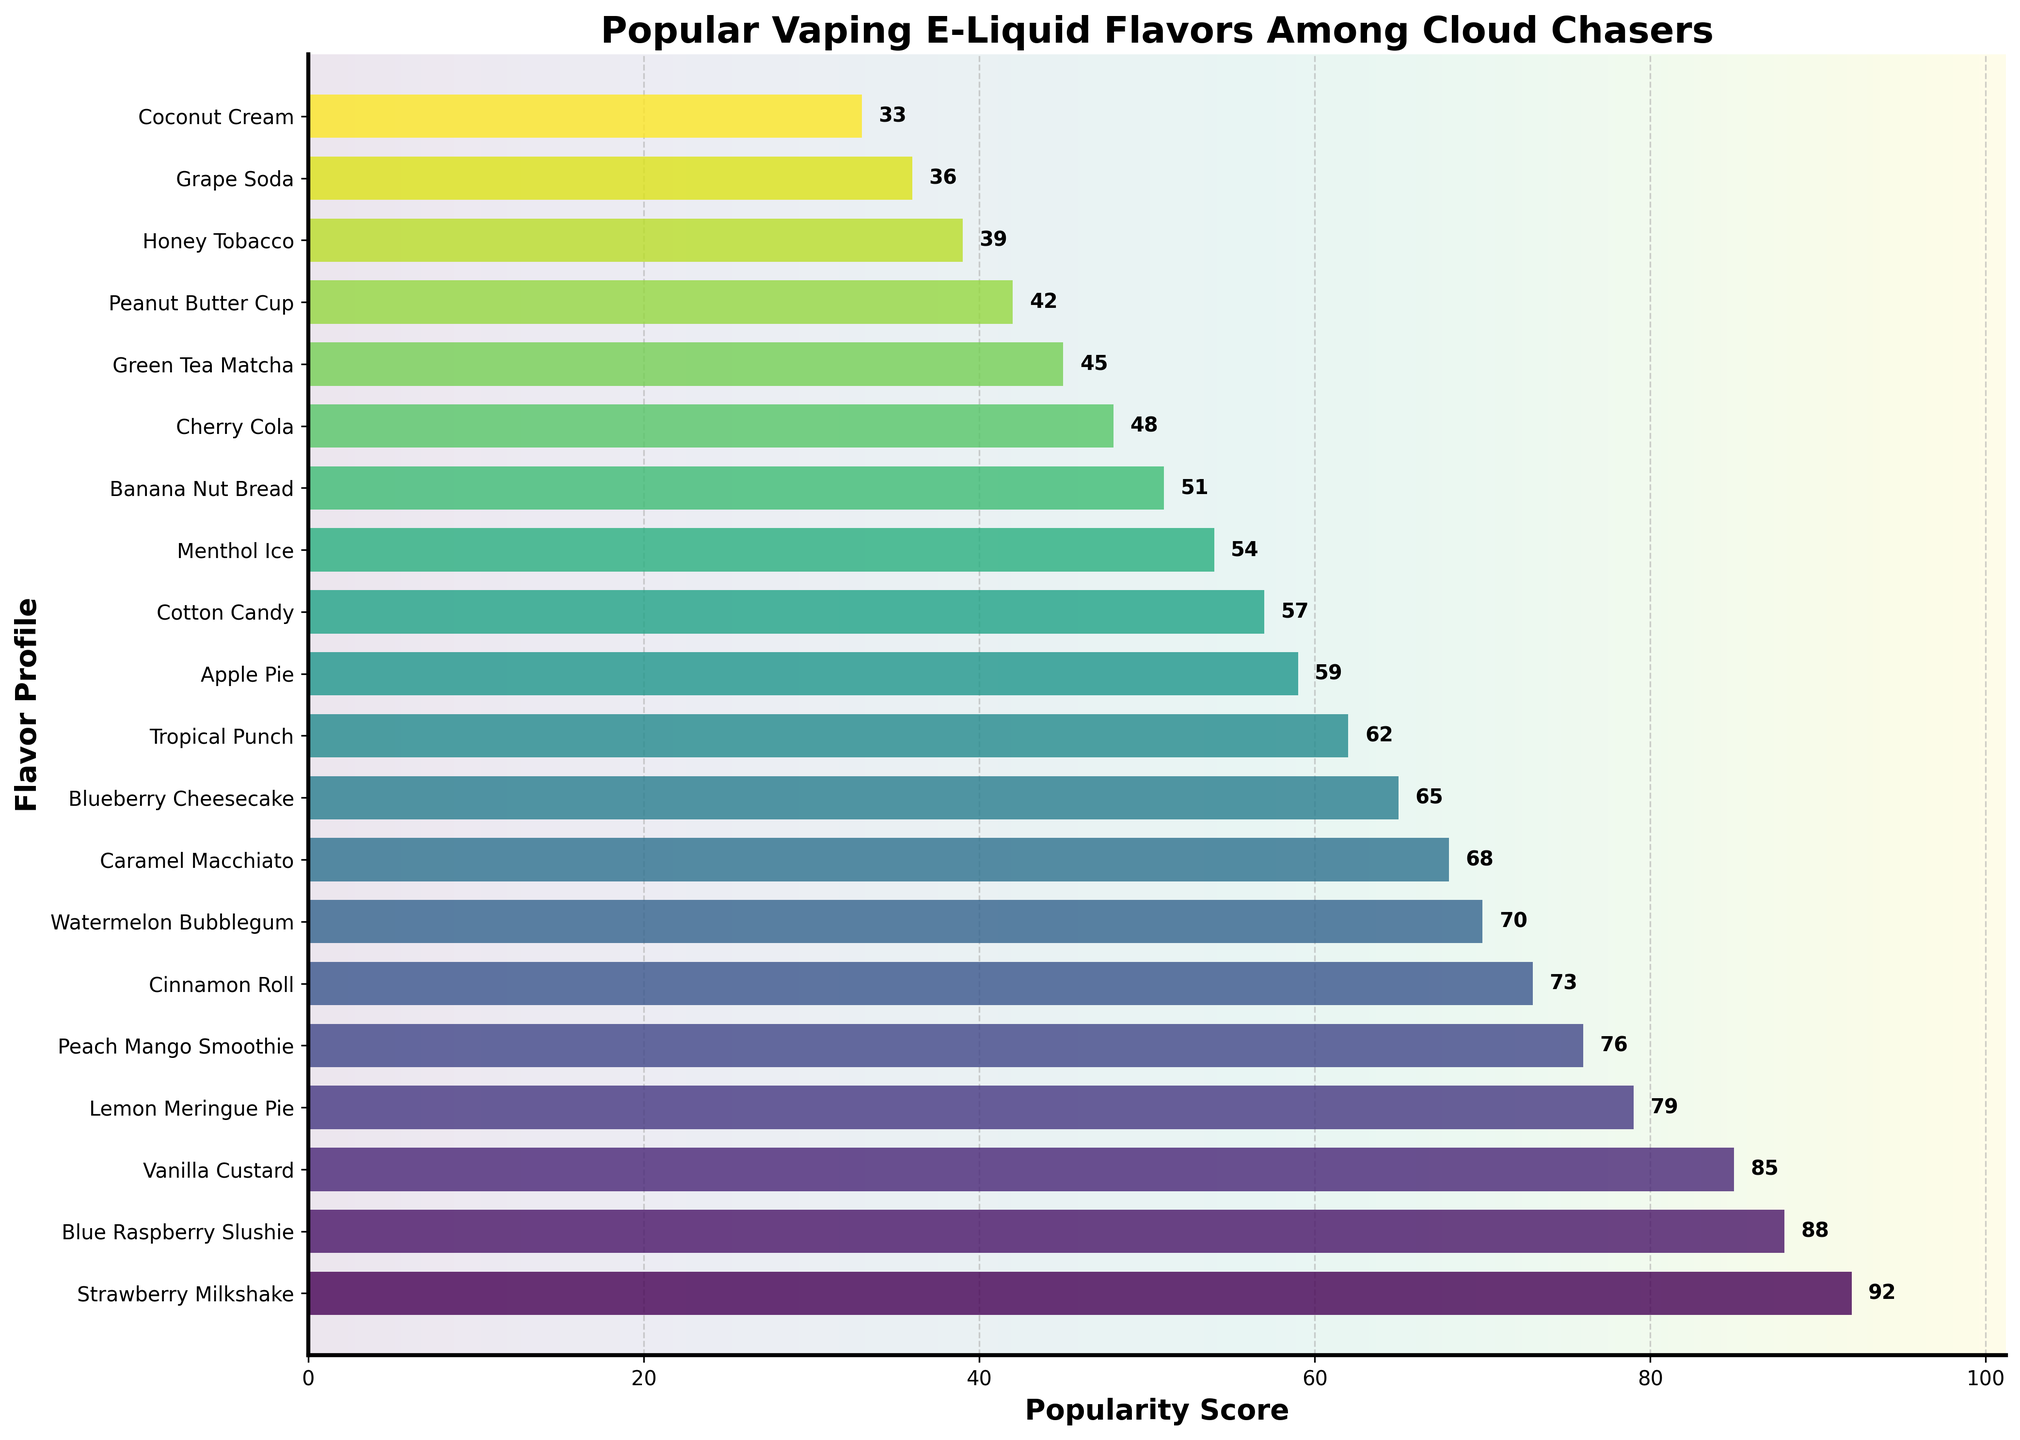what flavor profile has the highest popularity score? By looking at the top of the bar chart, we can see the bar with the highest length, which represents the flavor profile with the highest popularity score.
Answer: Strawberry Milkshake Which flavor profiles have a popularity score greater than 80? We need to identify the bars that extend beyond the 80 mark on the x-axis. By checking, we see that the bars corresponding to Strawberry Milkshake, Blue Raspberry Slushie, Vanilla Custard, and Lemon Meringue Pie are all greater than 80.
Answer: Strawberry Milkshake, Blue Raspberry Slushie, Vanilla Custard, Lemon Meringue Pie What is the difference in popularity score between Peach Mango Smoothie and Apple Pie? Look at the lengths of the bars for Peach Mango Smoothie and Apple Pie, and subtract the latter from the former. 76 (Peach Mango Smoothie) - 59 (Apple Pie) = 17.
Answer: 17 Which flavor profile is just below Vanilla Custard in popularity? Find the bar for Vanilla Custard and then look for the bar immediately below it. The bar below Vanilla Custard corresponds to Lemon Meringue Pie.
Answer: Lemon Meringue Pie Are there any flavor profiles with a popularity score of exactly 70? Check the bar lengths against the 70 mark on the x-axis. The bar for Watermelon Bubblegum matches this value.
Answer: Watermelon Bubblegum What are the top three most popular flavor profiles? Rank the flavor profiles by the length of their bars and select the top three. The first three bars in descending order of length are Strawberry Milkshake, Blue Raspberry Slushie, and Vanilla Custard.
Answer: Strawberry Milkshake, Blue Raspberry Slushie, Vanilla Custard How many flavor profiles have a popularity score less than 50? Count the bars that fall short of the 50 mark. By checking the plot, Banana Nut Bread, Cherry Cola, Green Tea Matcha, Peanut Butter Cup, Honey Tobacco, and Grape Soda all have scores less than 50.
Answer: 6 What is the total popularity score for the top three flavor profiles? Add the scores for Strawberry Milkshake (92), Blue Raspberry Slushie (88), and Vanilla Custard (85). 92 + 88 + 85 = 265.
Answer: 265 Which flavor profiles have a popularity score between 60 and 70? Identify the bars that fall within this range on the x-axis. Blueberry Cheesecake, Tropical Punch, and Watermelon Bubblegum match this range.
Answer: Blueberry Cheesecake, Tropical Punch, Watermelon Bubblegum Is Vanilla Custard more popular than Cinnamon Roll? Compare the lengths of the bars for Vanilla Custard and Cinnamon Roll. Vanilla Custard has a score of 85, while Cinnamon Roll has a score of 73, making Vanilla Custard more popular.
Answer: Yes 